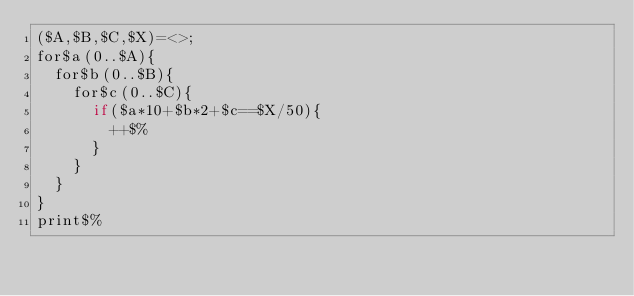Convert code to text. <code><loc_0><loc_0><loc_500><loc_500><_Perl_>($A,$B,$C,$X)=<>;
for$a(0..$A){
	for$b(0..$B){
		for$c(0..$C){
			if($a*10+$b*2+$c==$X/50){
				++$%
			}
		}
	}
}
print$%
</code> 